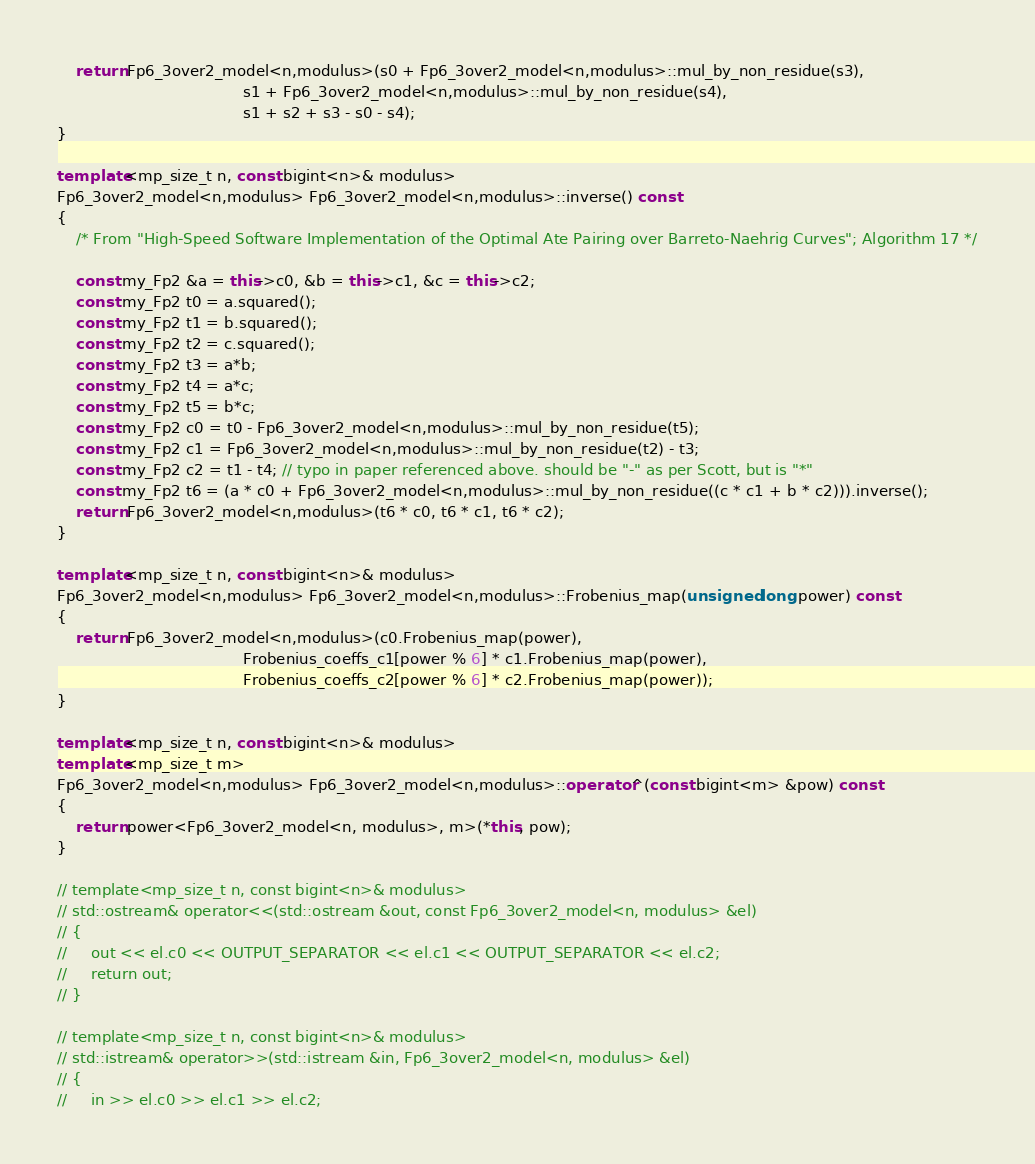<code> <loc_0><loc_0><loc_500><loc_500><_C++_>
    return Fp6_3over2_model<n,modulus>(s0 + Fp6_3over2_model<n,modulus>::mul_by_non_residue(s3),
                                       s1 + Fp6_3over2_model<n,modulus>::mul_by_non_residue(s4),
                                       s1 + s2 + s3 - s0 - s4);
}

template<mp_size_t n, const bigint<n>& modulus>
Fp6_3over2_model<n,modulus> Fp6_3over2_model<n,modulus>::inverse() const
{
    /* From "High-Speed Software Implementation of the Optimal Ate Pairing over Barreto-Naehrig Curves"; Algorithm 17 */

    const my_Fp2 &a = this->c0, &b = this->c1, &c = this->c2;
    const my_Fp2 t0 = a.squared();
    const my_Fp2 t1 = b.squared();
    const my_Fp2 t2 = c.squared();
    const my_Fp2 t3 = a*b;
    const my_Fp2 t4 = a*c;
    const my_Fp2 t5 = b*c;
    const my_Fp2 c0 = t0 - Fp6_3over2_model<n,modulus>::mul_by_non_residue(t5);
    const my_Fp2 c1 = Fp6_3over2_model<n,modulus>::mul_by_non_residue(t2) - t3;
    const my_Fp2 c2 = t1 - t4; // typo in paper referenced above. should be "-" as per Scott, but is "*"
    const my_Fp2 t6 = (a * c0 + Fp6_3over2_model<n,modulus>::mul_by_non_residue((c * c1 + b * c2))).inverse();
    return Fp6_3over2_model<n,modulus>(t6 * c0, t6 * c1, t6 * c2);
}

template<mp_size_t n, const bigint<n>& modulus>
Fp6_3over2_model<n,modulus> Fp6_3over2_model<n,modulus>::Frobenius_map(unsigned long power) const
{
    return Fp6_3over2_model<n,modulus>(c0.Frobenius_map(power),
                                       Frobenius_coeffs_c1[power % 6] * c1.Frobenius_map(power),
                                       Frobenius_coeffs_c2[power % 6] * c2.Frobenius_map(power));
}

template<mp_size_t n, const bigint<n>& modulus>
template<mp_size_t m>
Fp6_3over2_model<n,modulus> Fp6_3over2_model<n,modulus>::operator^(const bigint<m> &pow) const
{
    return power<Fp6_3over2_model<n, modulus>, m>(*this, pow);
}

// template<mp_size_t n, const bigint<n>& modulus>
// std::ostream& operator<<(std::ostream &out, const Fp6_3over2_model<n, modulus> &el)
// {
//     out << el.c0 << OUTPUT_SEPARATOR << el.c1 << OUTPUT_SEPARATOR << el.c2;
//     return out;
// }

// template<mp_size_t n, const bigint<n>& modulus>
// std::istream& operator>>(std::istream &in, Fp6_3over2_model<n, modulus> &el)
// {
//     in >> el.c0 >> el.c1 >> el.c2;</code> 